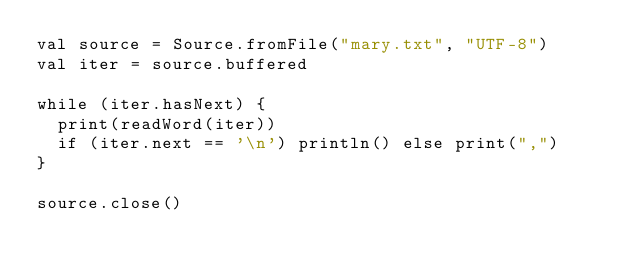Convert code to text. <code><loc_0><loc_0><loc_500><loc_500><_Scala_>val source = Source.fromFile("mary.txt", "UTF-8")
val iter = source.buffered

while (iter.hasNext) {
  print(readWord(iter))
  if (iter.next == '\n') println() else print(",")
}

source.close()
</code> 